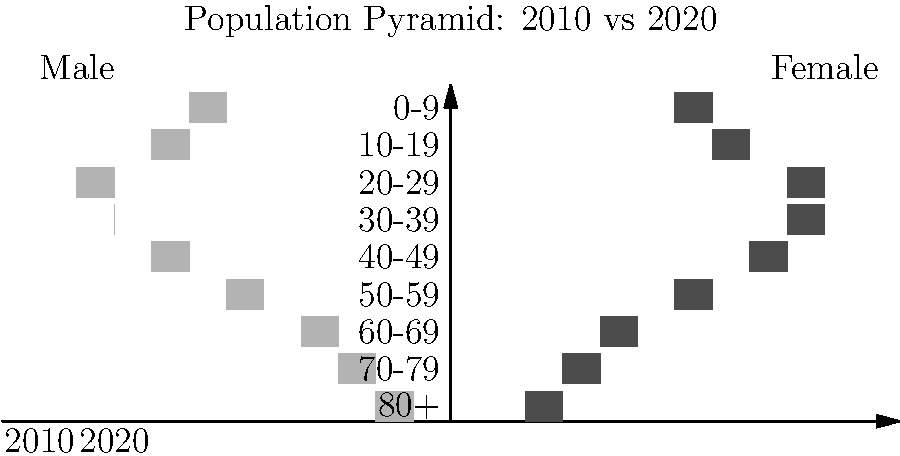As a political rival, you've been analyzing demographic shifts in your constituency. The population pyramid above shows changes between 2010 and 2020. Which age group demonstrates the most significant increase in the female population, and how might this impact your campaign strategy against Isa? To answer this question, we need to analyze the female side (right side) of the population pyramid for both 2010 and 2020:

1. Examine each age group on the female side, comparing the lighter bars (2010) to the darker bars (2020).
2. Identify the age group with the largest difference between 2010 and 2020.
3. The 60-69 age group shows the most noticeable increase.
4. This increase in the female 60-69 population could impact campaign strategy in several ways:
   a) Focus on issues important to older women, such as healthcare and retirement benefits.
   b) Address concerns about age-related discrimination in the workforce.
   c) Propose policies that support caregivers, as this age group often cares for elderly parents or grandchildren.
   d) Emphasize experience and wisdom in leadership, appealing to this growing demographic.
5. Isa's party may already be targeting this group, so developing a strong, differentiated message is crucial.
6. Consider how this demographic shift might influence other age groups, such as working-age adults supporting an aging population.
Answer: 60-69 age group; focus on healthcare, retirement, and caregiver support policies to appeal to growing older female demographic. 